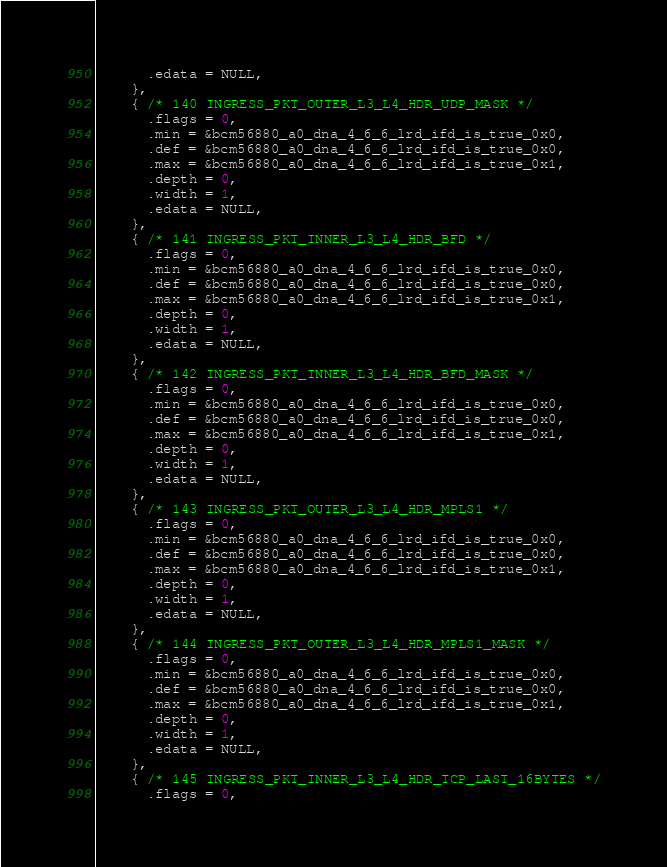<code> <loc_0><loc_0><loc_500><loc_500><_C_>      .edata = NULL,
    },
    { /* 140 INGRESS_PKT_OUTER_L3_L4_HDR_UDP_MASK */
      .flags = 0,
      .min = &bcm56880_a0_dna_4_6_6_lrd_ifd_is_true_0x0,
      .def = &bcm56880_a0_dna_4_6_6_lrd_ifd_is_true_0x0,
      .max = &bcm56880_a0_dna_4_6_6_lrd_ifd_is_true_0x1,
      .depth = 0,
      .width = 1,
      .edata = NULL,
    },
    { /* 141 INGRESS_PKT_INNER_L3_L4_HDR_BFD */
      .flags = 0,
      .min = &bcm56880_a0_dna_4_6_6_lrd_ifd_is_true_0x0,
      .def = &bcm56880_a0_dna_4_6_6_lrd_ifd_is_true_0x0,
      .max = &bcm56880_a0_dna_4_6_6_lrd_ifd_is_true_0x1,
      .depth = 0,
      .width = 1,
      .edata = NULL,
    },
    { /* 142 INGRESS_PKT_INNER_L3_L4_HDR_BFD_MASK */
      .flags = 0,
      .min = &bcm56880_a0_dna_4_6_6_lrd_ifd_is_true_0x0,
      .def = &bcm56880_a0_dna_4_6_6_lrd_ifd_is_true_0x0,
      .max = &bcm56880_a0_dna_4_6_6_lrd_ifd_is_true_0x1,
      .depth = 0,
      .width = 1,
      .edata = NULL,
    },
    { /* 143 INGRESS_PKT_OUTER_L3_L4_HDR_MPLS1 */
      .flags = 0,
      .min = &bcm56880_a0_dna_4_6_6_lrd_ifd_is_true_0x0,
      .def = &bcm56880_a0_dna_4_6_6_lrd_ifd_is_true_0x0,
      .max = &bcm56880_a0_dna_4_6_6_lrd_ifd_is_true_0x1,
      .depth = 0,
      .width = 1,
      .edata = NULL,
    },
    { /* 144 INGRESS_PKT_OUTER_L3_L4_HDR_MPLS1_MASK */
      .flags = 0,
      .min = &bcm56880_a0_dna_4_6_6_lrd_ifd_is_true_0x0,
      .def = &bcm56880_a0_dna_4_6_6_lrd_ifd_is_true_0x0,
      .max = &bcm56880_a0_dna_4_6_6_lrd_ifd_is_true_0x1,
      .depth = 0,
      .width = 1,
      .edata = NULL,
    },
    { /* 145 INGRESS_PKT_INNER_L3_L4_HDR_TCP_LAST_16BYTES */
      .flags = 0,</code> 